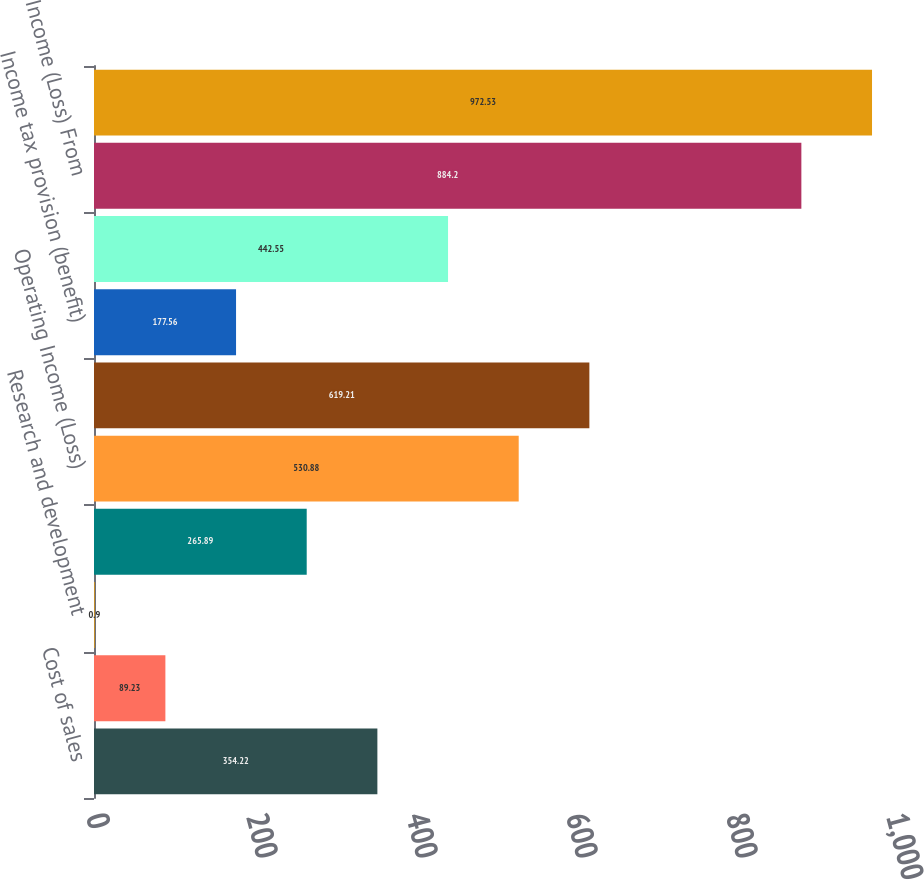Convert chart to OTSL. <chart><loc_0><loc_0><loc_500><loc_500><bar_chart><fcel>Cost of sales<fcel>Selling and administrative<fcel>Research and development<fcel>Other income (expense) net<fcel>Operating Income (Loss)<fcel>Income (Loss) Before Taxes (B)<fcel>Income tax provision (benefit)<fcel>Income (Loss) From Operations<fcel>Income (Loss) From<fcel>Net Income (Loss) From<nl><fcel>354.22<fcel>89.23<fcel>0.9<fcel>265.89<fcel>530.88<fcel>619.21<fcel>177.56<fcel>442.55<fcel>884.2<fcel>972.53<nl></chart> 